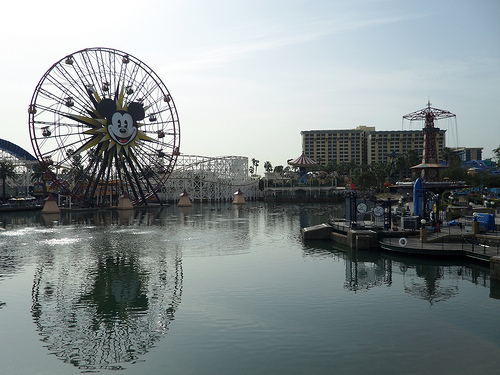<image>
Is the mickey mouse above the water? Yes. The mickey mouse is positioned above the water in the vertical space, higher up in the scene. 